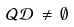Convert formula to latex. <formula><loc_0><loc_0><loc_500><loc_500>\mathcal { Q } \mathcal { D } \, \neq \, \emptyset</formula> 